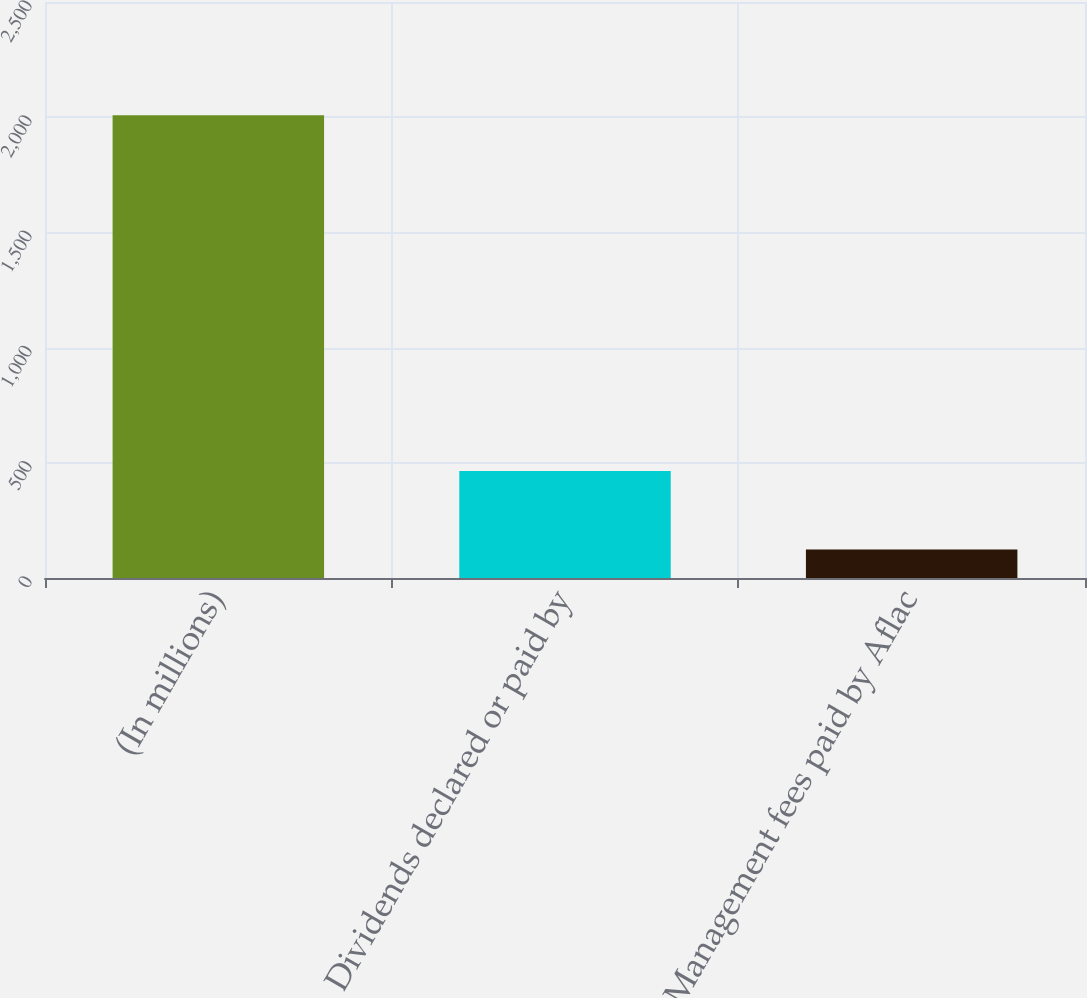<chart> <loc_0><loc_0><loc_500><loc_500><bar_chart><fcel>(In millions)<fcel>Dividends declared or paid by<fcel>Management fees paid by Aflac<nl><fcel>2009<fcel>464<fcel>124<nl></chart> 